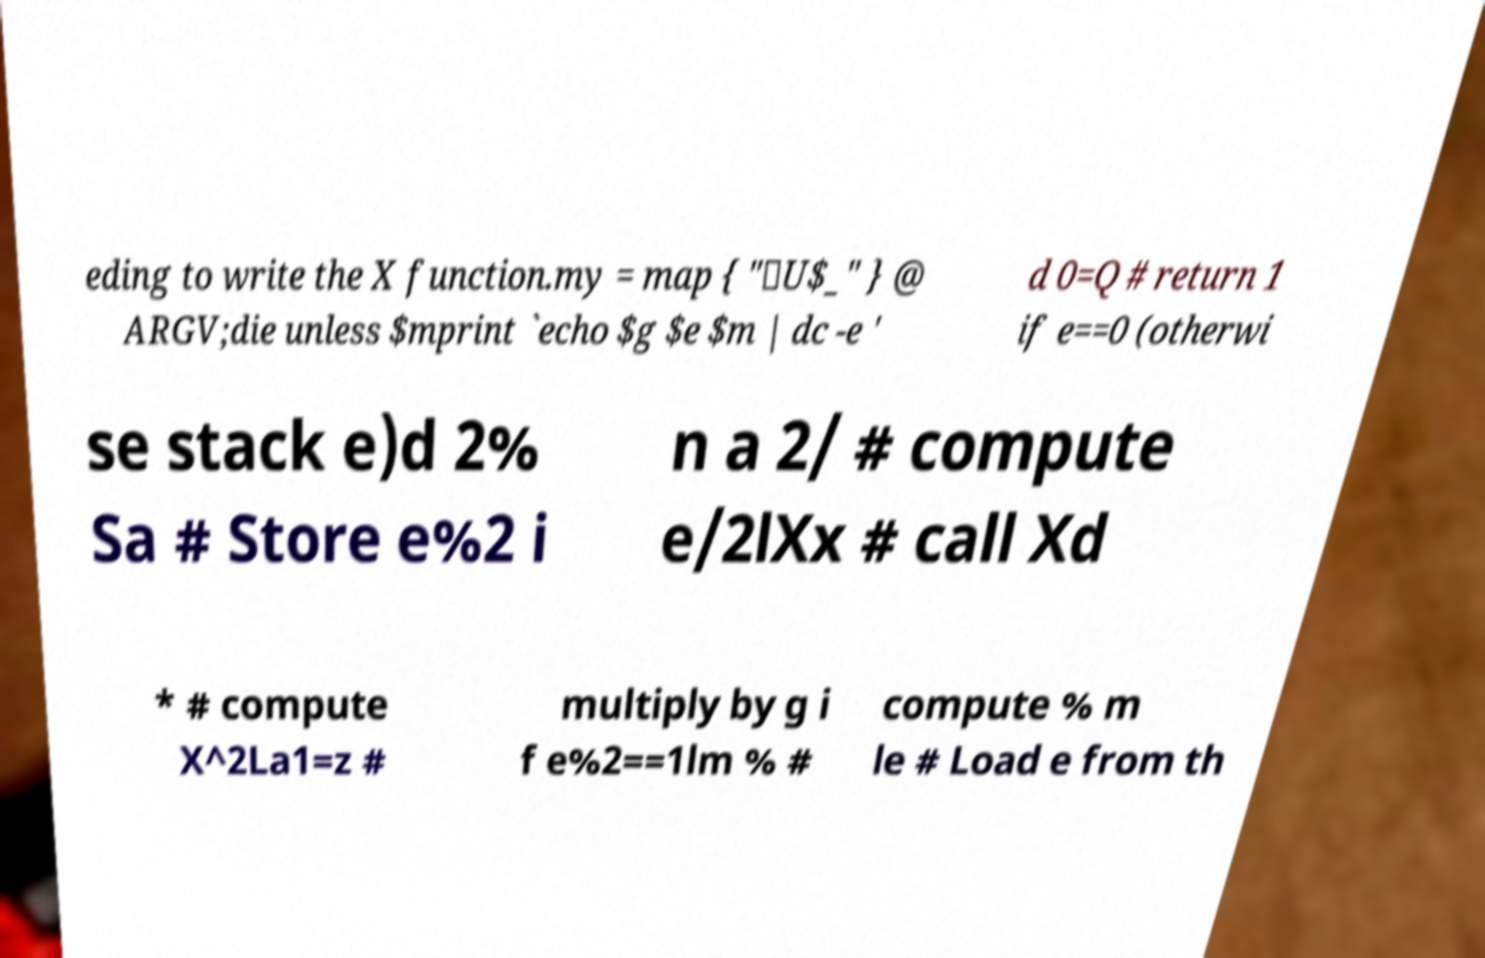Could you assist in decoding the text presented in this image and type it out clearly? eding to write the X function.my = map { "\U$_" } @ ARGV;die unless $mprint `echo $g $e $m | dc -e ' d 0=Q # return 1 if e==0 (otherwi se stack e)d 2% Sa # Store e%2 i n a 2/ # compute e/2lXx # call Xd * # compute X^2La1=z # multiply by g i f e%2==1lm % # compute % m le # Load e from th 